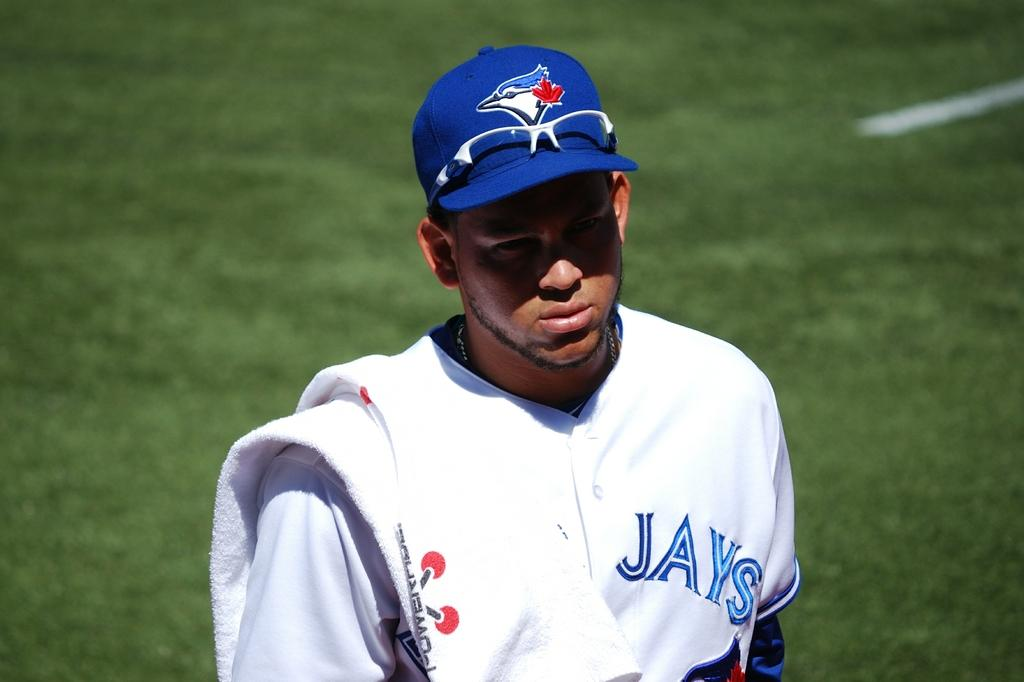<image>
Render a clear and concise summary of the photo. A player wears a blue hat and a white shirt with "Jays" in blue letters. 